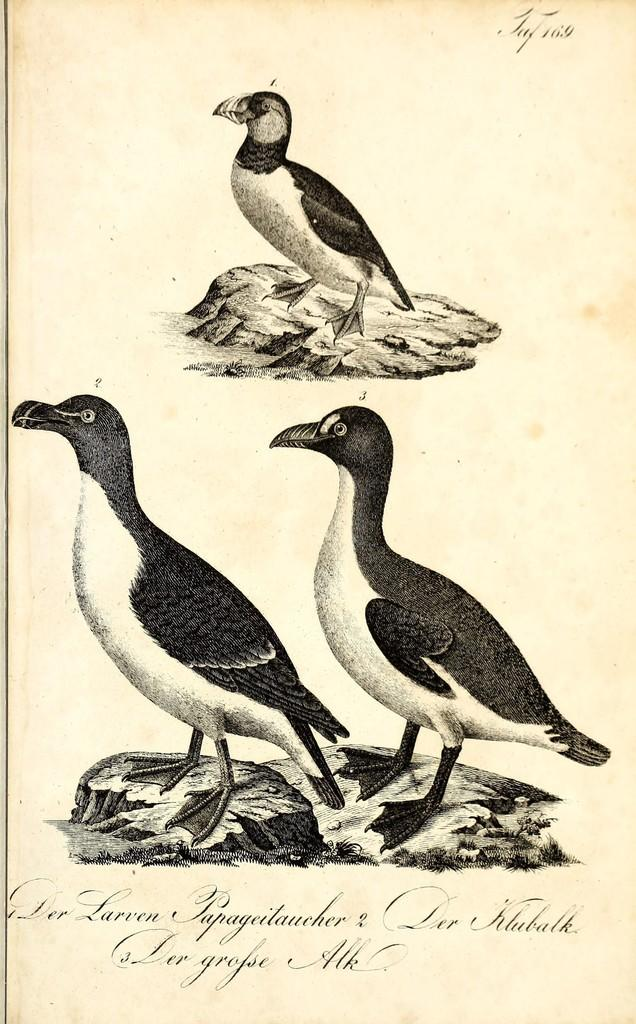What type of image is featured in the picture? The image contains an art image. Can you describe the subjects in the art image? There are three birds in the image. Is there any text associated with the art image? Yes, there is text at the bottom of the image. What type of mine is depicted in the image? There is no mine present in the image; it features an art image with three birds and text at the bottom. Can you tell me the relation between the birds and the text in the image? There is no information provided about the relation between the birds and the text in the image. 